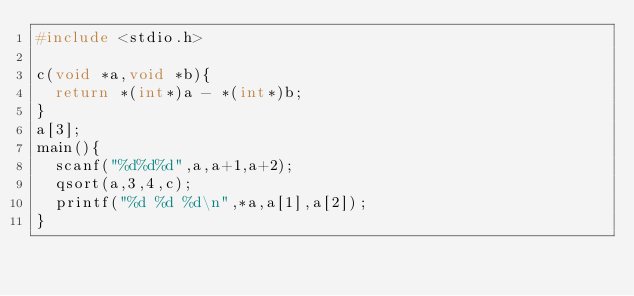Convert code to text. <code><loc_0><loc_0><loc_500><loc_500><_C_>#include <stdio.h>

c(void *a,void *b){
  return *(int*)a - *(int*)b;
}
a[3];
main(){
  scanf("%d%d%d",a,a+1,a+2);
  qsort(a,3,4,c);
  printf("%d %d %d\n",*a,a[1],a[2]);
}</code> 